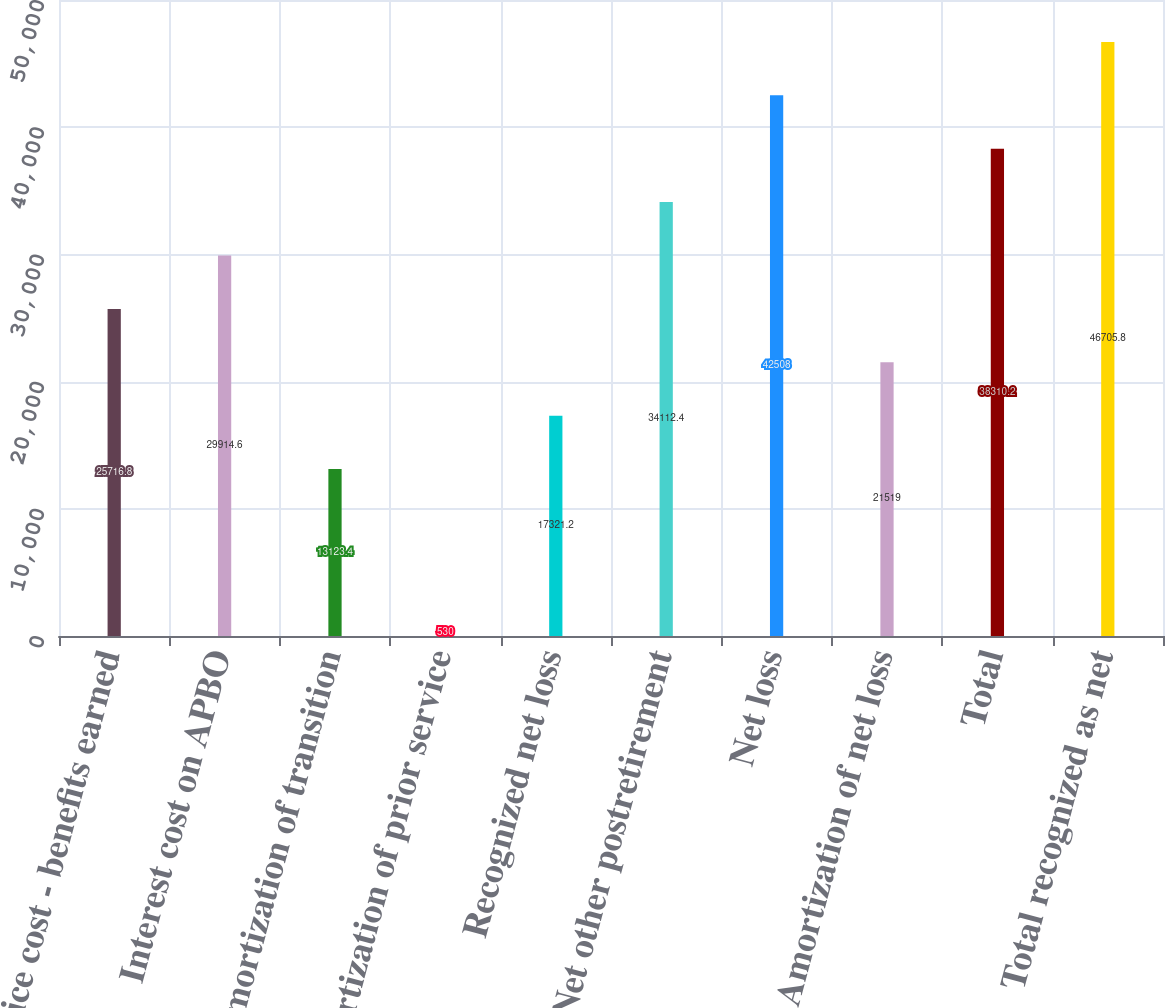Convert chart to OTSL. <chart><loc_0><loc_0><loc_500><loc_500><bar_chart><fcel>Service cost - benefits earned<fcel>Interest cost on APBO<fcel>Amortization of transition<fcel>Amortization of prior service<fcel>Recognized net loss<fcel>Net other postretirement<fcel>Net loss<fcel>Amortization of net loss<fcel>Total<fcel>Total recognized as net<nl><fcel>25716.8<fcel>29914.6<fcel>13123.4<fcel>530<fcel>17321.2<fcel>34112.4<fcel>42508<fcel>21519<fcel>38310.2<fcel>46705.8<nl></chart> 